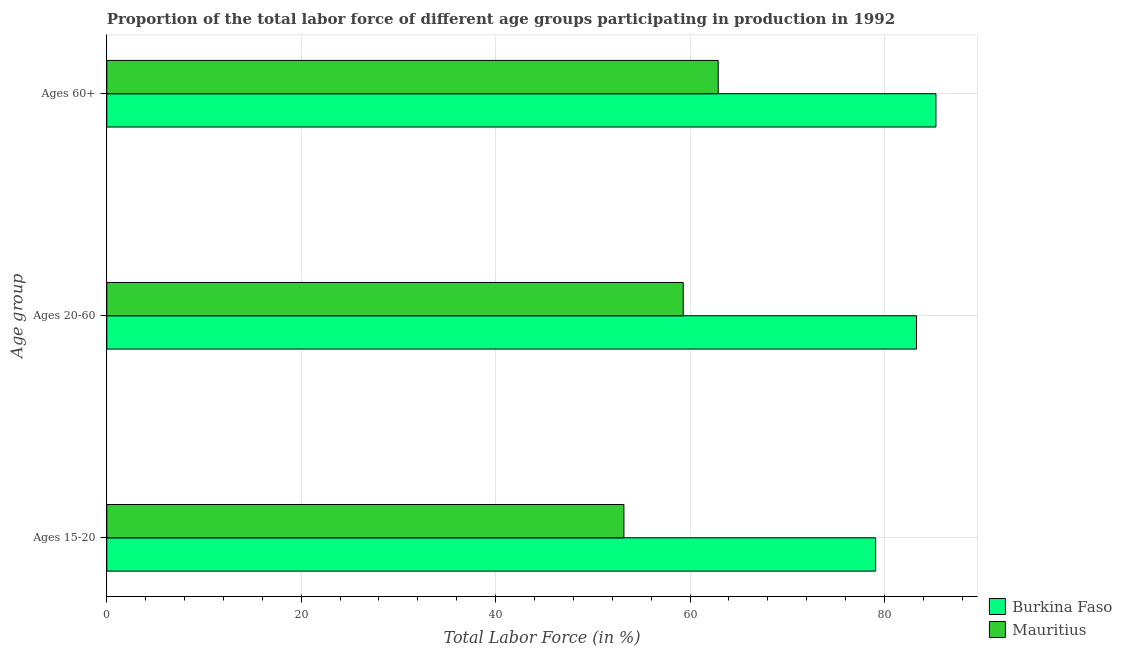How many different coloured bars are there?
Your answer should be compact. 2. How many bars are there on the 2nd tick from the bottom?
Your answer should be very brief. 2. What is the label of the 3rd group of bars from the top?
Offer a very short reply. Ages 15-20. What is the percentage of labor force within the age group 15-20 in Burkina Faso?
Keep it short and to the point. 79.1. Across all countries, what is the maximum percentage of labor force above age 60?
Offer a terse response. 85.3. Across all countries, what is the minimum percentage of labor force within the age group 20-60?
Your answer should be compact. 59.3. In which country was the percentage of labor force within the age group 15-20 maximum?
Ensure brevity in your answer.  Burkina Faso. In which country was the percentage of labor force within the age group 15-20 minimum?
Your answer should be compact. Mauritius. What is the total percentage of labor force above age 60 in the graph?
Offer a terse response. 148.2. What is the difference between the percentage of labor force within the age group 20-60 in Mauritius and that in Burkina Faso?
Keep it short and to the point. -24. What is the difference between the percentage of labor force above age 60 in Burkina Faso and the percentage of labor force within the age group 15-20 in Mauritius?
Provide a short and direct response. 32.1. What is the average percentage of labor force above age 60 per country?
Offer a very short reply. 74.1. What is the difference between the percentage of labor force within the age group 15-20 and percentage of labor force within the age group 20-60 in Burkina Faso?
Provide a succinct answer. -4.2. What is the ratio of the percentage of labor force above age 60 in Burkina Faso to that in Mauritius?
Ensure brevity in your answer.  1.36. Is the difference between the percentage of labor force within the age group 20-60 in Burkina Faso and Mauritius greater than the difference between the percentage of labor force within the age group 15-20 in Burkina Faso and Mauritius?
Make the answer very short. No. What is the difference between the highest and the second highest percentage of labor force above age 60?
Keep it short and to the point. 22.4. What is the difference between the highest and the lowest percentage of labor force above age 60?
Give a very brief answer. 22.4. What does the 1st bar from the top in Ages 60+ represents?
Your response must be concise. Mauritius. What does the 1st bar from the bottom in Ages 60+ represents?
Offer a very short reply. Burkina Faso. Is it the case that in every country, the sum of the percentage of labor force within the age group 15-20 and percentage of labor force within the age group 20-60 is greater than the percentage of labor force above age 60?
Your answer should be very brief. Yes. Are all the bars in the graph horizontal?
Offer a very short reply. Yes. Does the graph contain any zero values?
Your answer should be very brief. No. How many legend labels are there?
Keep it short and to the point. 2. How are the legend labels stacked?
Give a very brief answer. Vertical. What is the title of the graph?
Ensure brevity in your answer.  Proportion of the total labor force of different age groups participating in production in 1992. What is the label or title of the X-axis?
Give a very brief answer. Total Labor Force (in %). What is the label or title of the Y-axis?
Provide a succinct answer. Age group. What is the Total Labor Force (in %) in Burkina Faso in Ages 15-20?
Offer a terse response. 79.1. What is the Total Labor Force (in %) of Mauritius in Ages 15-20?
Your response must be concise. 53.2. What is the Total Labor Force (in %) in Burkina Faso in Ages 20-60?
Your answer should be very brief. 83.3. What is the Total Labor Force (in %) in Mauritius in Ages 20-60?
Offer a very short reply. 59.3. What is the Total Labor Force (in %) of Burkina Faso in Ages 60+?
Your response must be concise. 85.3. What is the Total Labor Force (in %) in Mauritius in Ages 60+?
Keep it short and to the point. 62.9. Across all Age group, what is the maximum Total Labor Force (in %) of Burkina Faso?
Provide a succinct answer. 85.3. Across all Age group, what is the maximum Total Labor Force (in %) in Mauritius?
Offer a terse response. 62.9. Across all Age group, what is the minimum Total Labor Force (in %) of Burkina Faso?
Provide a succinct answer. 79.1. Across all Age group, what is the minimum Total Labor Force (in %) in Mauritius?
Give a very brief answer. 53.2. What is the total Total Labor Force (in %) in Burkina Faso in the graph?
Your response must be concise. 247.7. What is the total Total Labor Force (in %) in Mauritius in the graph?
Your answer should be compact. 175.4. What is the difference between the Total Labor Force (in %) in Burkina Faso in Ages 15-20 and that in Ages 20-60?
Make the answer very short. -4.2. What is the difference between the Total Labor Force (in %) in Mauritius in Ages 15-20 and that in Ages 60+?
Your response must be concise. -9.7. What is the difference between the Total Labor Force (in %) in Burkina Faso in Ages 20-60 and that in Ages 60+?
Your response must be concise. -2. What is the difference between the Total Labor Force (in %) of Burkina Faso in Ages 15-20 and the Total Labor Force (in %) of Mauritius in Ages 20-60?
Your answer should be compact. 19.8. What is the difference between the Total Labor Force (in %) of Burkina Faso in Ages 15-20 and the Total Labor Force (in %) of Mauritius in Ages 60+?
Ensure brevity in your answer.  16.2. What is the difference between the Total Labor Force (in %) in Burkina Faso in Ages 20-60 and the Total Labor Force (in %) in Mauritius in Ages 60+?
Keep it short and to the point. 20.4. What is the average Total Labor Force (in %) of Burkina Faso per Age group?
Your response must be concise. 82.57. What is the average Total Labor Force (in %) of Mauritius per Age group?
Your answer should be compact. 58.47. What is the difference between the Total Labor Force (in %) of Burkina Faso and Total Labor Force (in %) of Mauritius in Ages 15-20?
Your answer should be very brief. 25.9. What is the difference between the Total Labor Force (in %) of Burkina Faso and Total Labor Force (in %) of Mauritius in Ages 20-60?
Offer a very short reply. 24. What is the difference between the Total Labor Force (in %) of Burkina Faso and Total Labor Force (in %) of Mauritius in Ages 60+?
Give a very brief answer. 22.4. What is the ratio of the Total Labor Force (in %) of Burkina Faso in Ages 15-20 to that in Ages 20-60?
Provide a short and direct response. 0.95. What is the ratio of the Total Labor Force (in %) in Mauritius in Ages 15-20 to that in Ages 20-60?
Give a very brief answer. 0.9. What is the ratio of the Total Labor Force (in %) of Burkina Faso in Ages 15-20 to that in Ages 60+?
Your answer should be compact. 0.93. What is the ratio of the Total Labor Force (in %) of Mauritius in Ages 15-20 to that in Ages 60+?
Provide a short and direct response. 0.85. What is the ratio of the Total Labor Force (in %) in Burkina Faso in Ages 20-60 to that in Ages 60+?
Offer a very short reply. 0.98. What is the ratio of the Total Labor Force (in %) in Mauritius in Ages 20-60 to that in Ages 60+?
Provide a succinct answer. 0.94. What is the difference between the highest and the lowest Total Labor Force (in %) of Burkina Faso?
Your response must be concise. 6.2. What is the difference between the highest and the lowest Total Labor Force (in %) in Mauritius?
Your answer should be very brief. 9.7. 